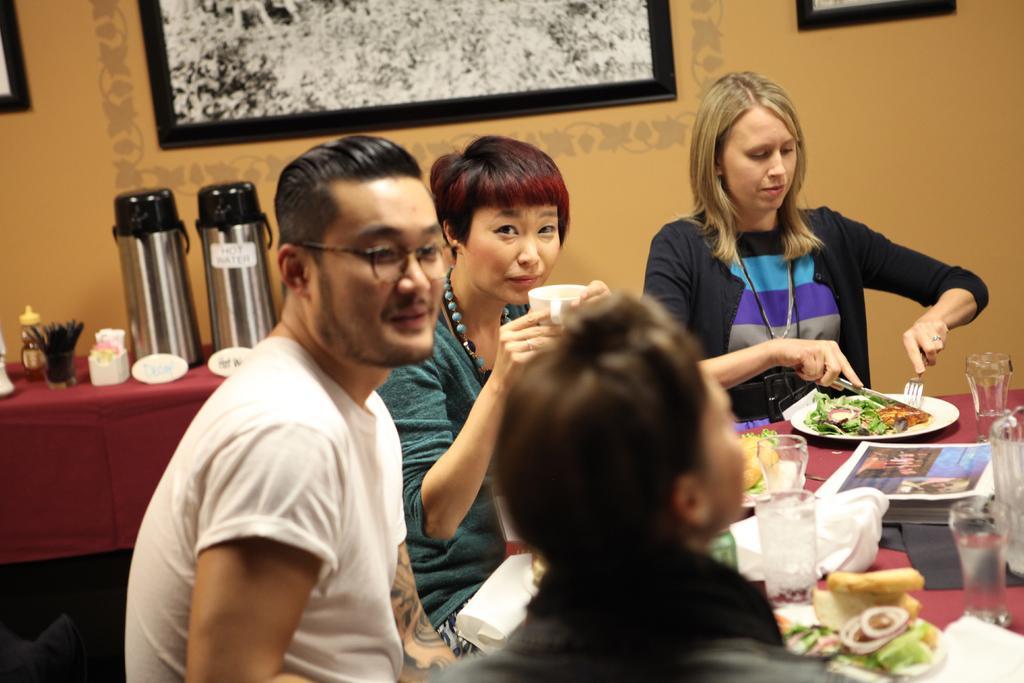In one or two sentences, can you explain what this image depicts? In the middle there is a table on the table there is a glass ,plate ,paper and some food items. In the middle there is a woman she wear black jacket, her hair is small. In the middle there is a person. On the left there is a man and woman ,woman is drinking something ,man is staring at a person. In the back ground there is a table on that table there is a bottle ,jugs and some other items. In the background there is a wall and photo frame. 